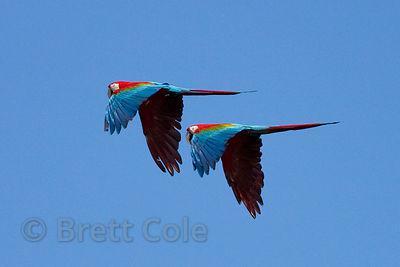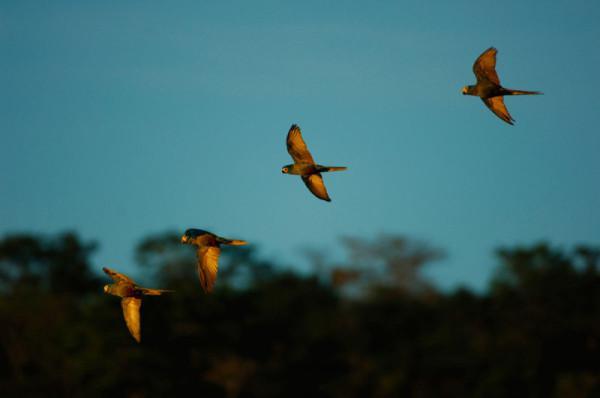The first image is the image on the left, the second image is the image on the right. Given the left and right images, does the statement "The left photo depicts only two parrots." hold true? Answer yes or no. Yes. The first image is the image on the left, the second image is the image on the right. For the images displayed, is the sentence "Two birds are flying the air in the image on the left" factually correct? Answer yes or no. Yes. 